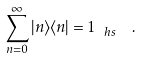Convert formula to latex. <formula><loc_0><loc_0><loc_500><loc_500>\sum _ { n = 0 } ^ { \infty } | n \rangle \langle n | = { 1 } _ { \ h s } \ \ .</formula> 